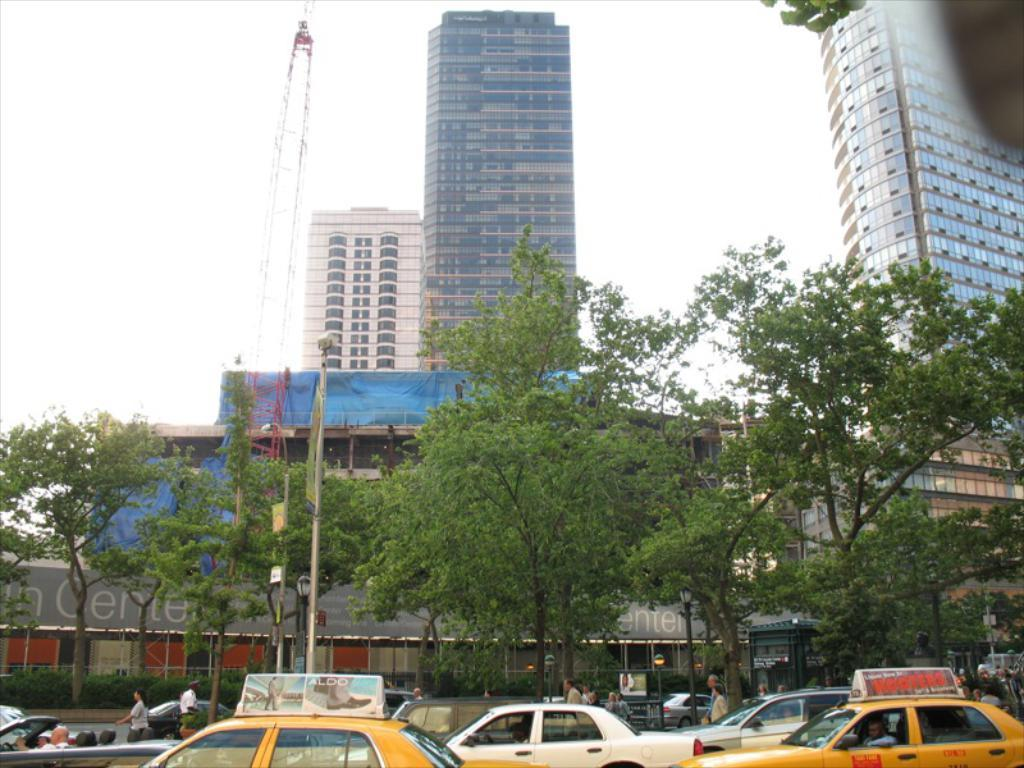<image>
Provide a brief description of the given image. The advertisement on top of the taxi is for Aloo shoes. 